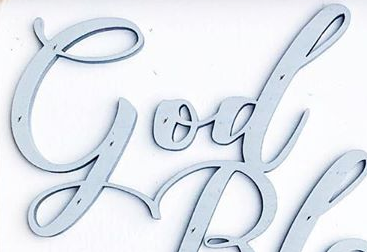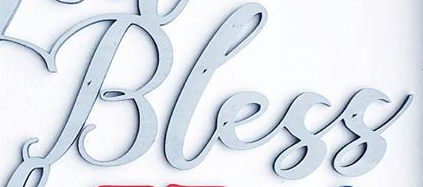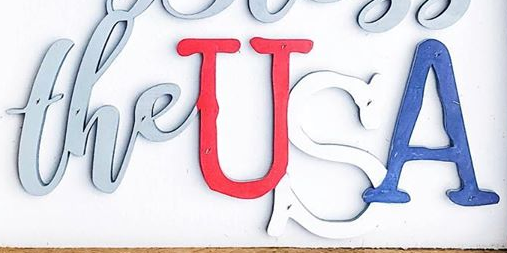What text is displayed in these images sequentially, separated by a semicolon? God; Bless; theUSA 